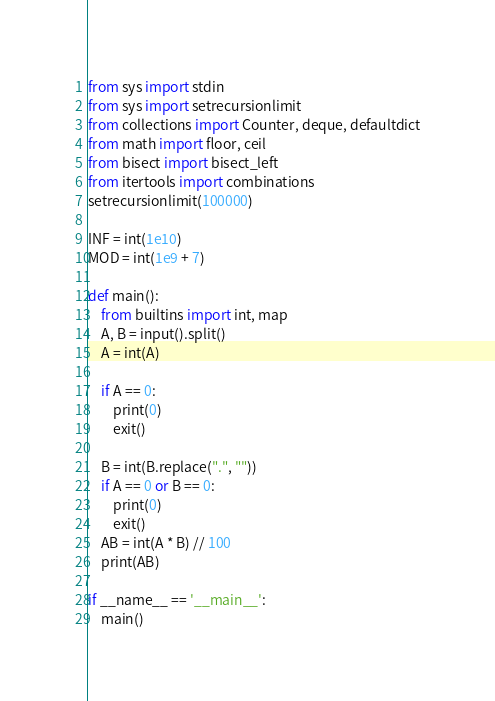Convert code to text. <code><loc_0><loc_0><loc_500><loc_500><_Python_>from sys import stdin
from sys import setrecursionlimit
from collections import Counter, deque, defaultdict
from math import floor, ceil
from bisect import bisect_left
from itertools import combinations
setrecursionlimit(100000)

INF = int(1e10)
MOD = int(1e9 + 7)

def main():
    from builtins import int, map
    A, B = input().split()
    A = int(A)

    if A == 0:
        print(0)
        exit()

    B = int(B.replace(".", ""))
    if A == 0 or B == 0:
        print(0)
        exit()
    AB = int(A * B) // 100
    print(AB)

if __name__ == '__main__':
    main()</code> 